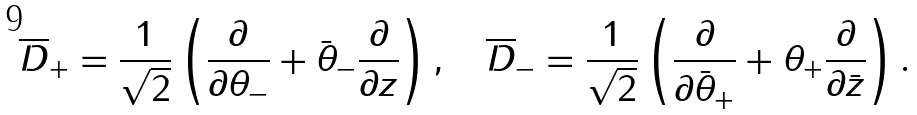Convert formula to latex. <formula><loc_0><loc_0><loc_500><loc_500>\overline { D } _ { + } = \frac { 1 } { \sqrt { 2 } } \left ( \frac { \partial } { \partial \theta _ { - } } + \bar { \theta } _ { - } \frac { \partial } { \partial z } \right ) , \quad \overline { D } _ { - } = \frac { 1 } { \sqrt { 2 } } \left ( \frac { \partial } { \partial \bar { \theta } _ { + } } + \theta _ { + } \frac { \partial } { \partial \bar { z } } \right ) .</formula> 